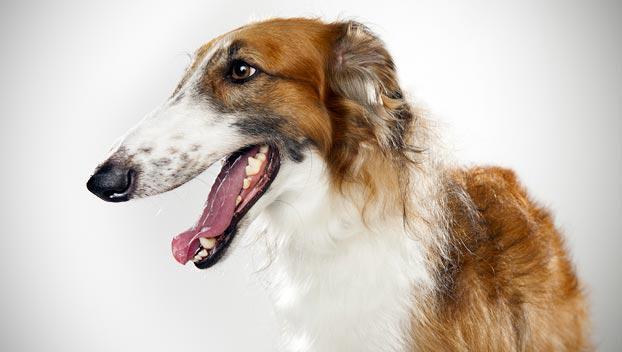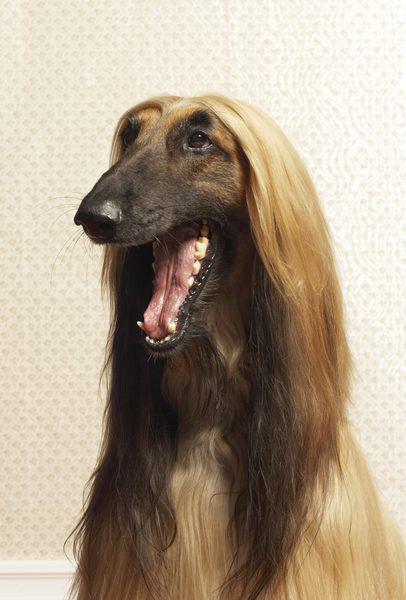The first image is the image on the left, the second image is the image on the right. For the images displayed, is the sentence "An image shows a hound standing on the grassy ground." factually correct? Answer yes or no. No. 